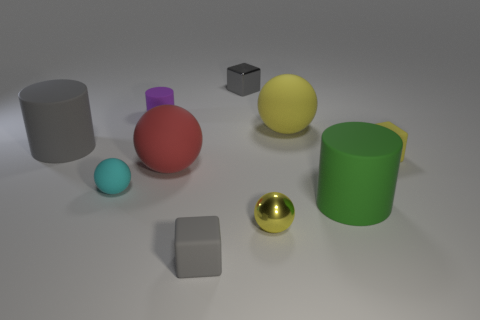What is the shape of the yellow thing that is behind the small rubber cube that is behind the red rubber ball?
Make the answer very short. Sphere. Do the yellow shiny object and the tiny purple object have the same shape?
Your answer should be very brief. No. There is a small object that is the same color as the small metal sphere; what is it made of?
Ensure brevity in your answer.  Rubber. Is the color of the tiny rubber ball the same as the small cylinder?
Provide a short and direct response. No. There is a rubber block to the right of the small gray thing behind the tiny metallic ball; how many small yellow rubber cubes are on the left side of it?
Your answer should be very brief. 0. There is a gray thing that is made of the same material as the tiny yellow ball; what is its shape?
Give a very brief answer. Cube. What is the material of the gray object in front of the small rubber object that is to the right of the small rubber thing that is in front of the tiny cyan sphere?
Your response must be concise. Rubber. How many objects are either big things on the left side of the purple thing or red metal cubes?
Your answer should be very brief. 1. How many other things are there of the same shape as the red thing?
Keep it short and to the point. 3. Is the number of cyan spheres behind the small gray metallic block greater than the number of red rubber balls?
Offer a terse response. No. 